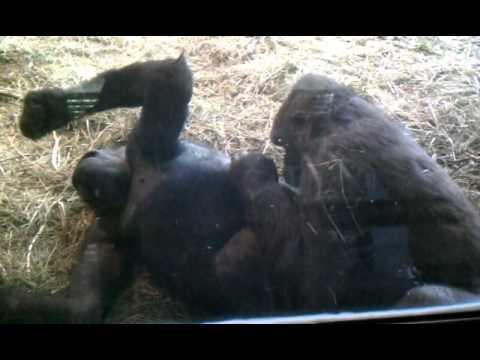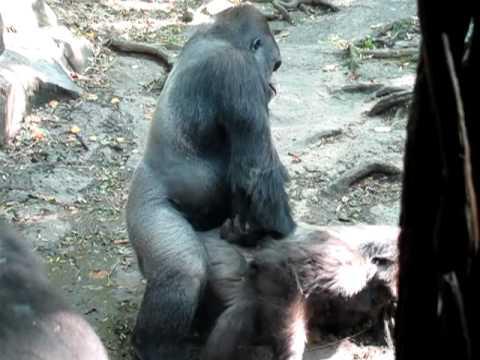The first image is the image on the left, the second image is the image on the right. Evaluate the accuracy of this statement regarding the images: "There is a single male ape not looking at the camera.". Is it true? Answer yes or no. No. 